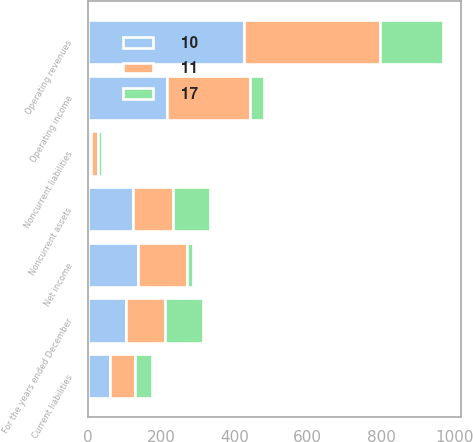Convert chart to OTSL. <chart><loc_0><loc_0><loc_500><loc_500><stacked_bar_chart><ecel><fcel>For the years ended December<fcel>Operating revenues<fcel>Operating income<fcel>Net income<fcel>Noncurrent assets<fcel>Current liabilities<fcel>Noncurrent liabilities<nl><fcel>10<fcel>105<fcel>427<fcel>216<fcel>136<fcel>124<fcel>60<fcel>10<nl><fcel>11<fcel>105<fcel>371<fcel>227<fcel>136<fcel>108<fcel>70<fcel>17<nl><fcel>17<fcel>105<fcel>170<fcel>37<fcel>16<fcel>102<fcel>46<fcel>11<nl></chart> 